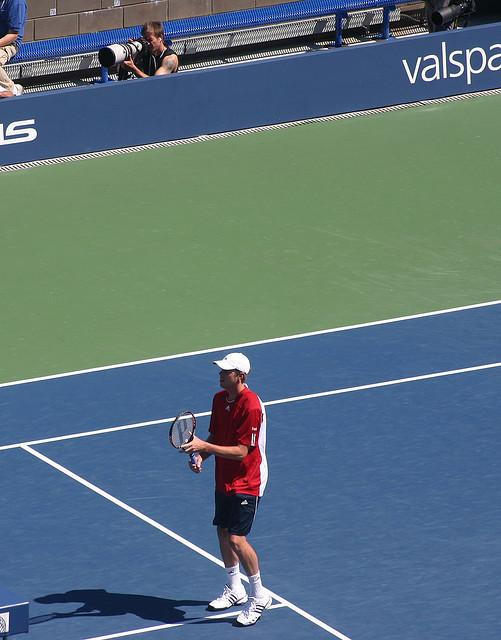How many visible stripes are in his right shoe?

Choices:
A) three
B) zero
C) one
D) two three 